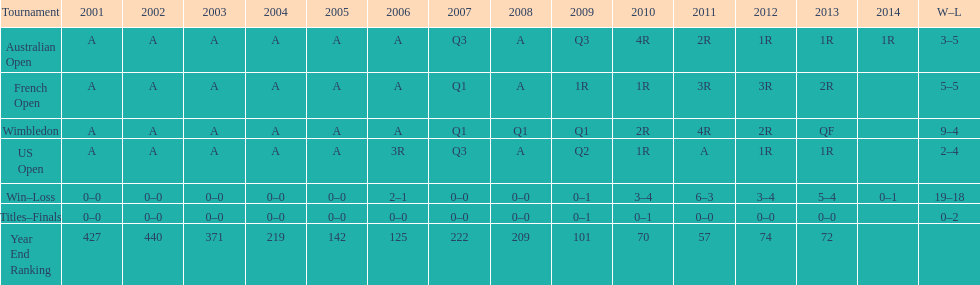Which years was a ranking below 200 achieved? 2005, 2006, 2009, 2010, 2011, 2012, 2013. 